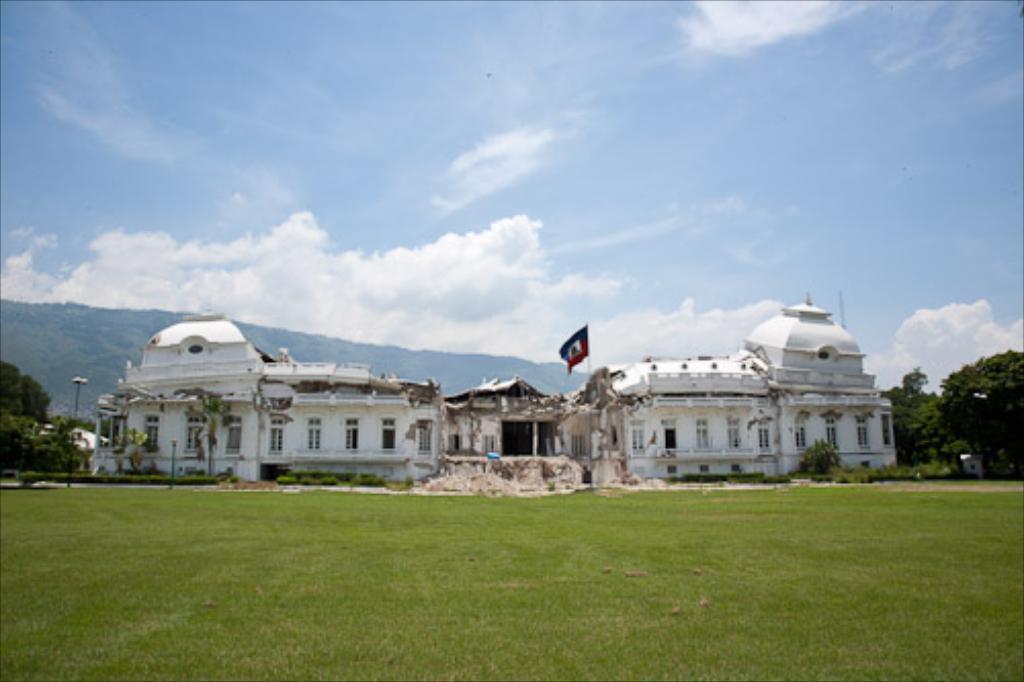Please provide a concise description of this image. In this picture we can see a building with windows, flag, trees, grass, poles, mountains and in the background we can see the sky with clouds. 